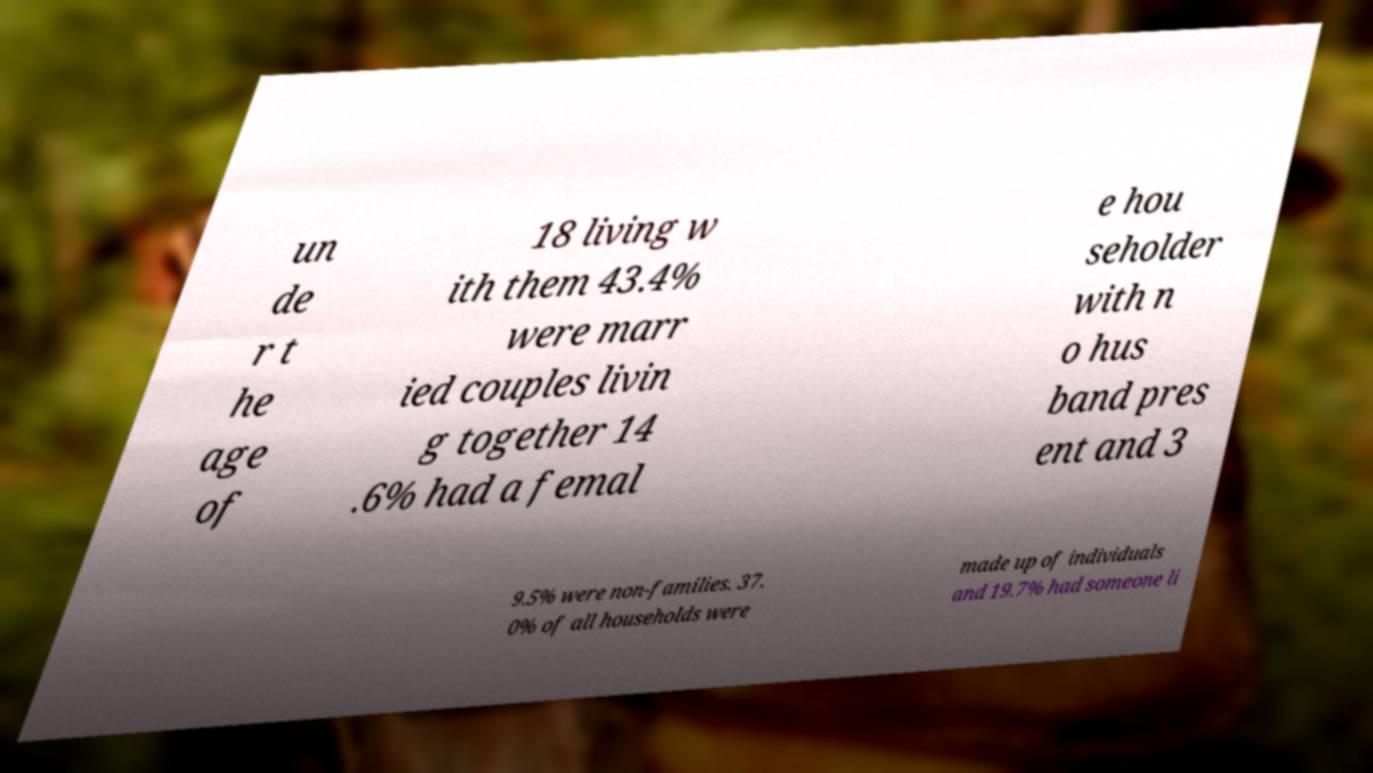There's text embedded in this image that I need extracted. Can you transcribe it verbatim? un de r t he age of 18 living w ith them 43.4% were marr ied couples livin g together 14 .6% had a femal e hou seholder with n o hus band pres ent and 3 9.5% were non-families. 37. 0% of all households were made up of individuals and 19.7% had someone li 